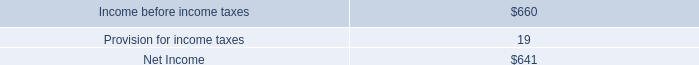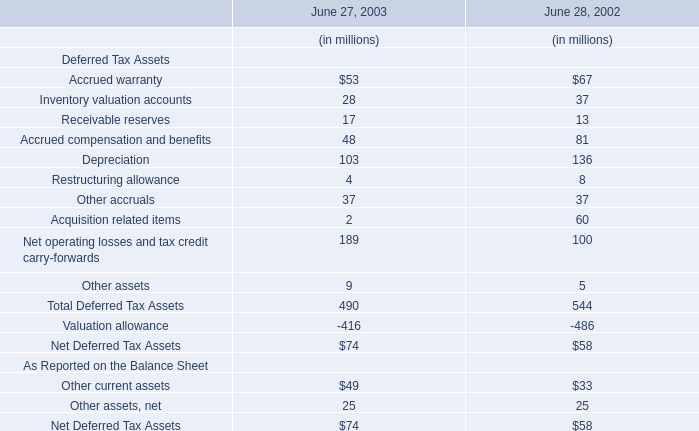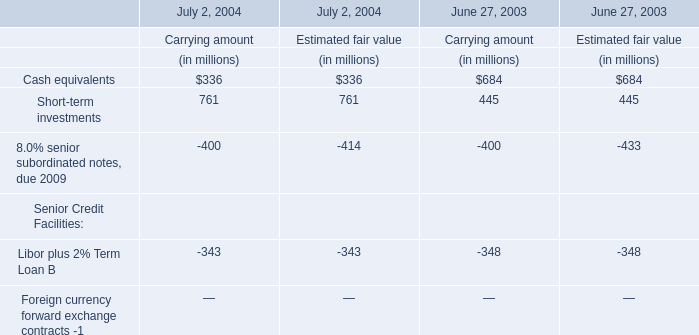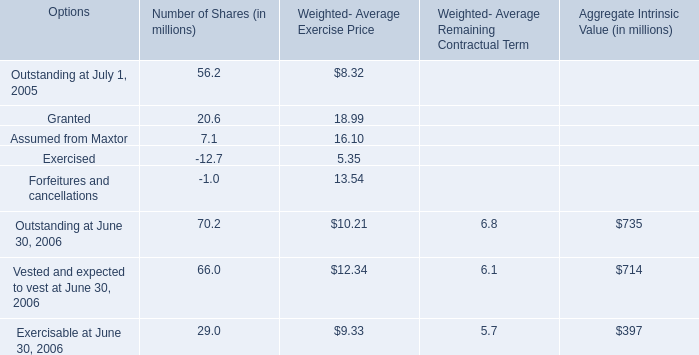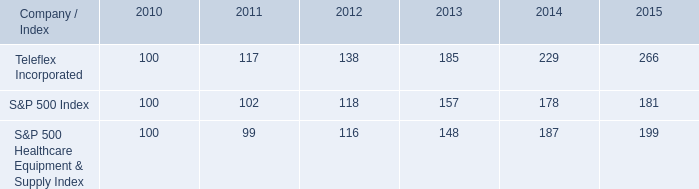based on the table , how much percent did the healthcare sector outperform the overall market in this 5 year period? 
Computations: ((199 - 100) - (181 - 100))
Answer: 18.0. 